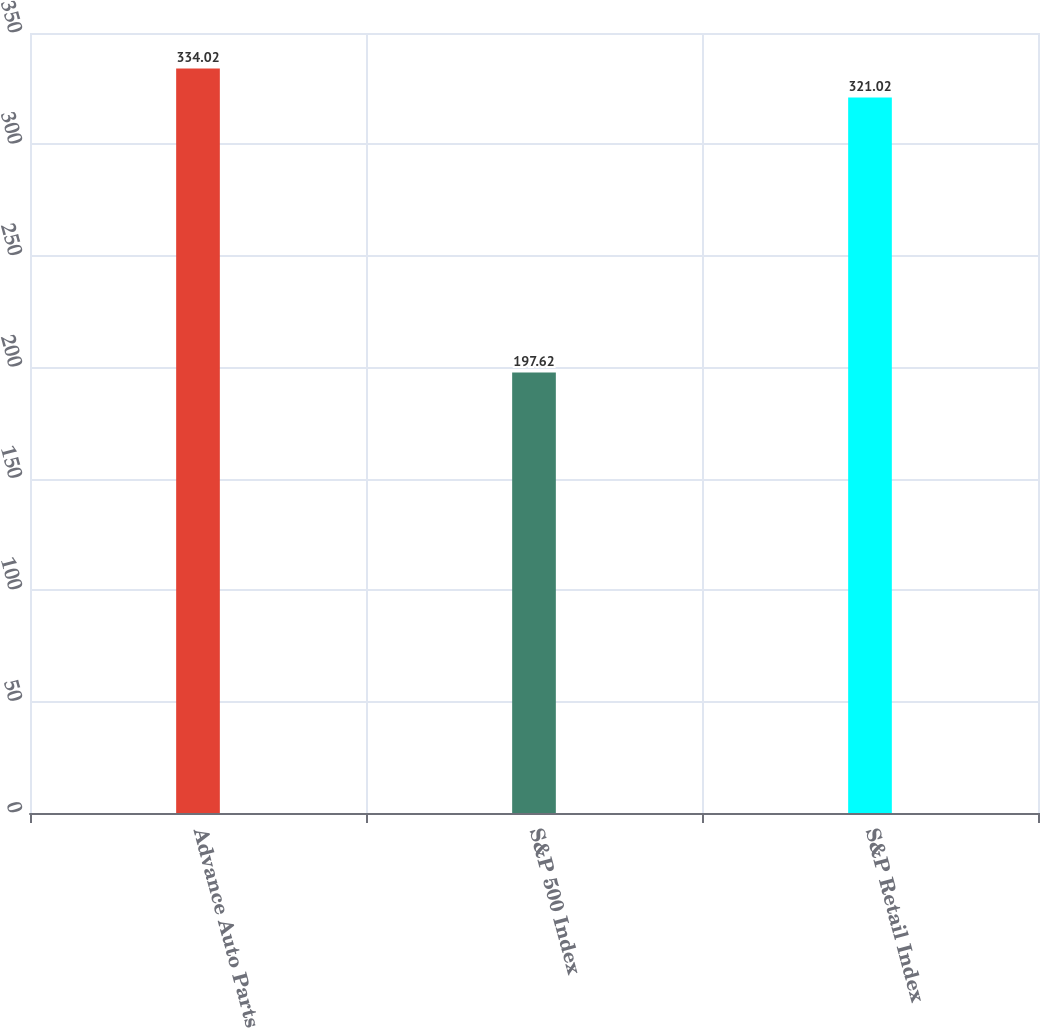Convert chart. <chart><loc_0><loc_0><loc_500><loc_500><bar_chart><fcel>Advance Auto Parts<fcel>S&P 500 Index<fcel>S&P Retail Index<nl><fcel>334.02<fcel>197.62<fcel>321.02<nl></chart> 